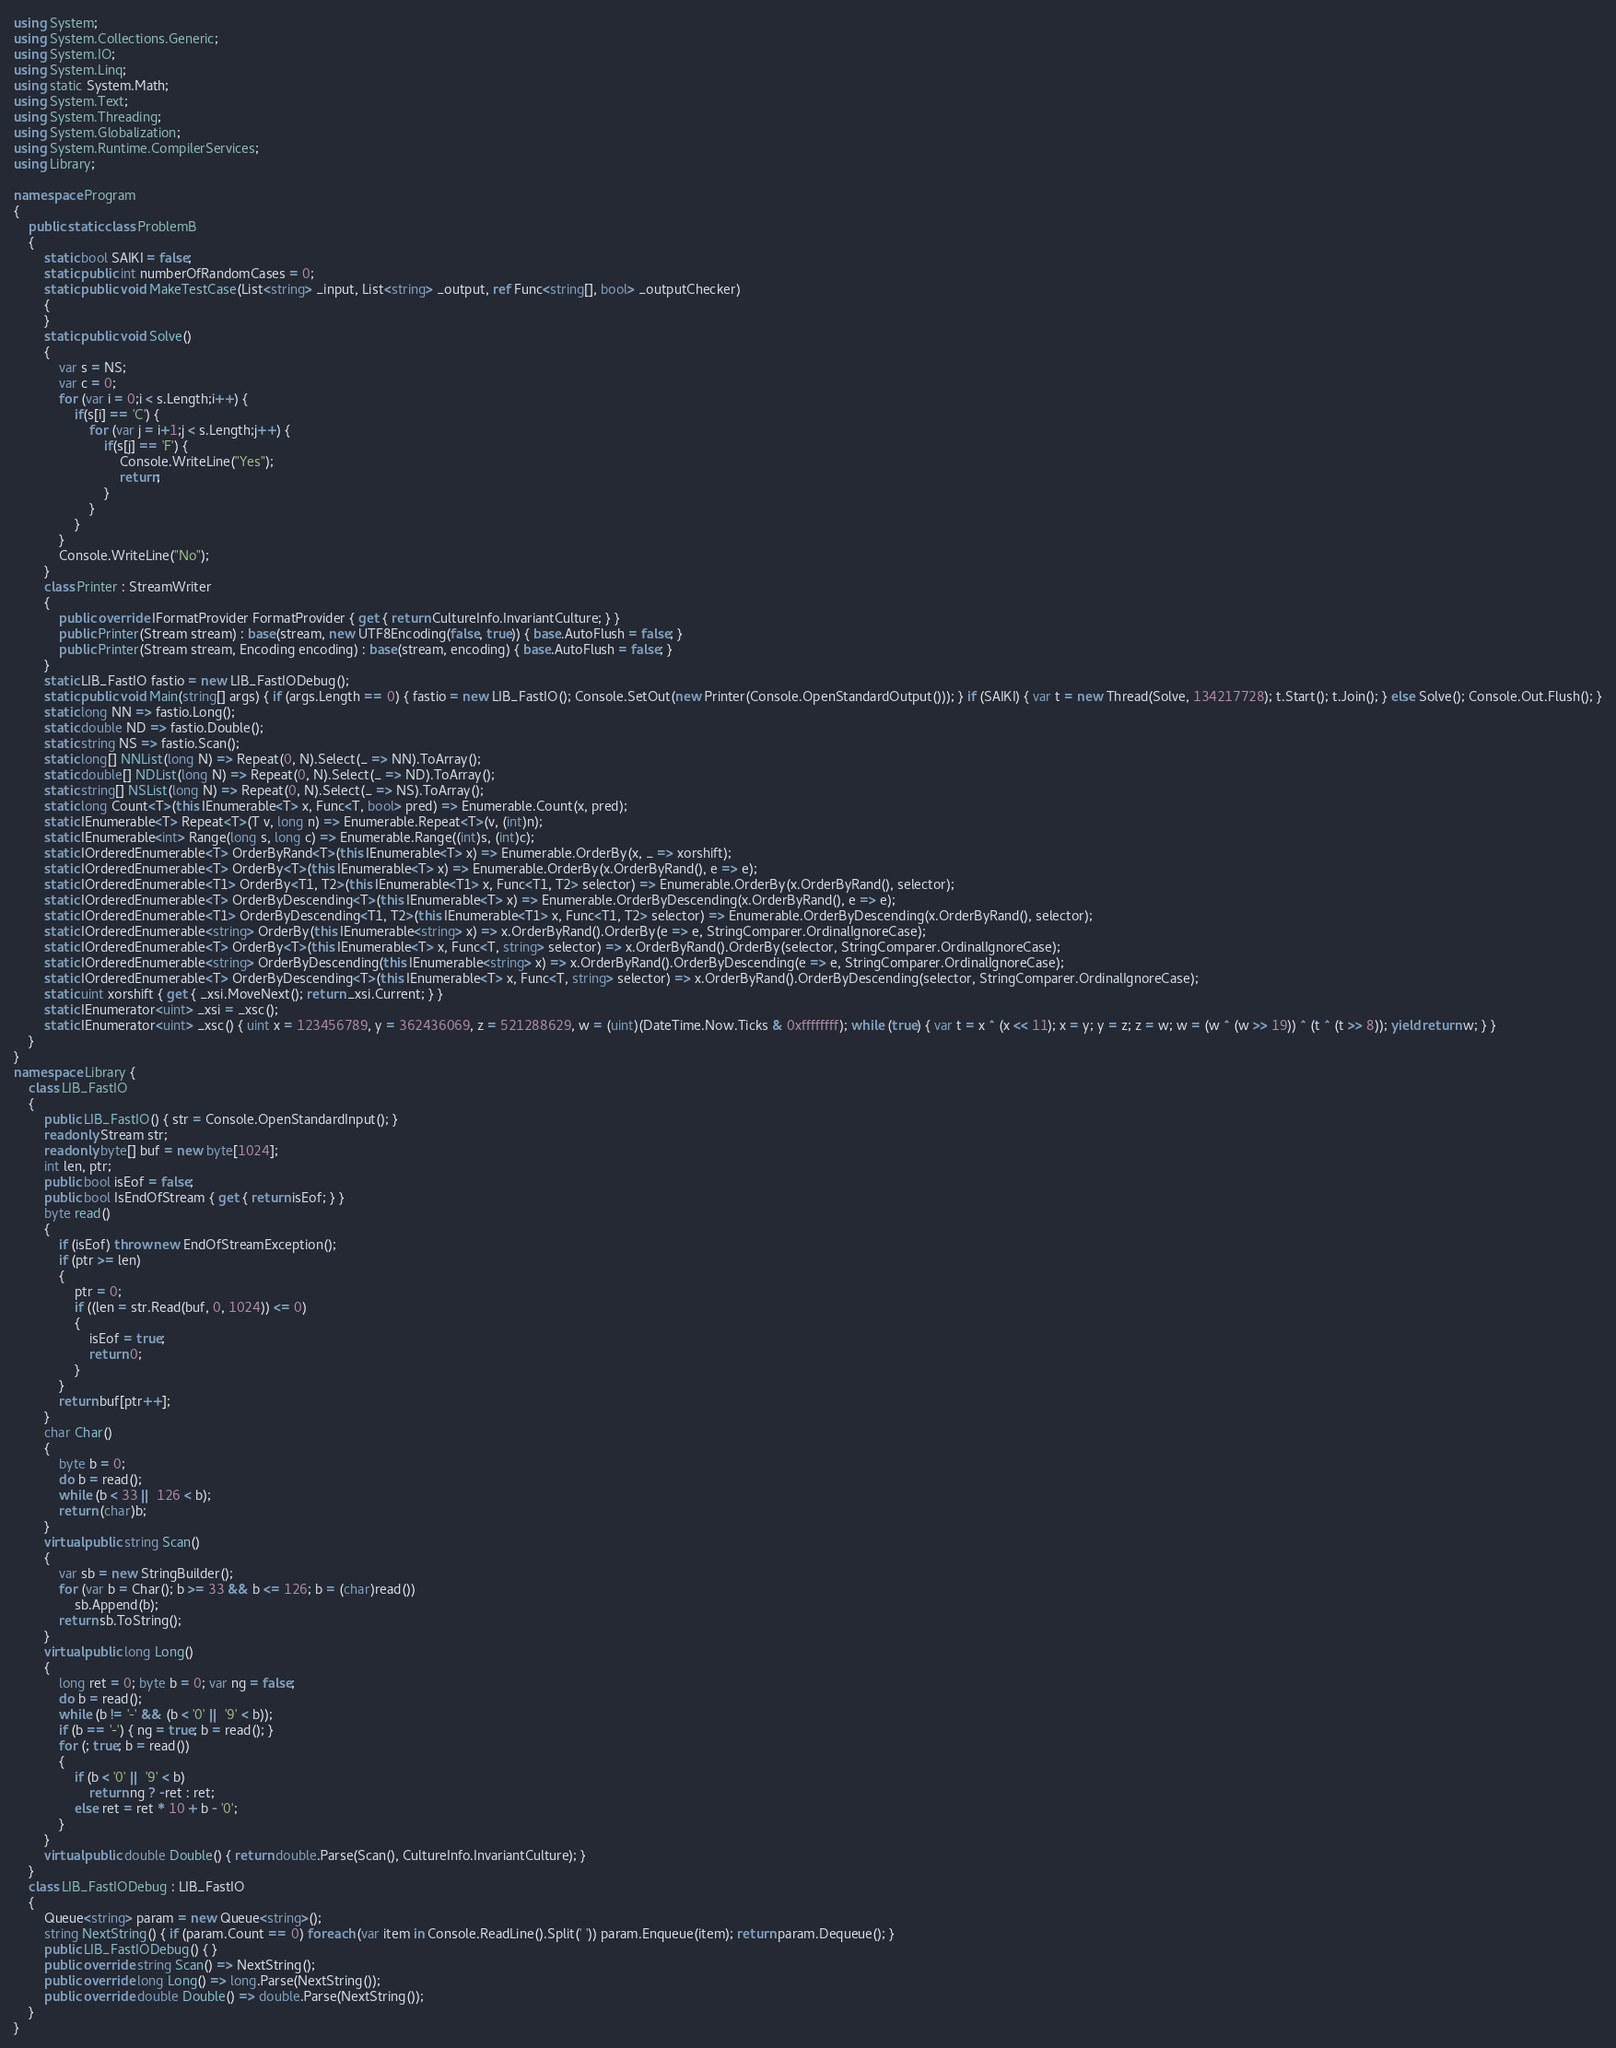Convert code to text. <code><loc_0><loc_0><loc_500><loc_500><_C#_>using System;
using System.Collections.Generic;
using System.IO;
using System.Linq;
using static System.Math;
using System.Text;
using System.Threading;
using System.Globalization;
using System.Runtime.CompilerServices;
using Library;

namespace Program
{
    public static class ProblemB
    {
        static bool SAIKI = false;
        static public int numberOfRandomCases = 0;
        static public void MakeTestCase(List<string> _input, List<string> _output, ref Func<string[], bool> _outputChecker)
        {
        }
        static public void Solve()
        {
            var s = NS;
            var c = 0;
            for (var i = 0;i < s.Length;i++) {
                if(s[i] == 'C') {
                    for (var j = i+1;j < s.Length;j++) {
                        if(s[j] == 'F') {
                            Console.WriteLine("Yes");
                            return;
                        }
                    }
                }
            }
            Console.WriteLine("No");
        }
        class Printer : StreamWriter
        {
            public override IFormatProvider FormatProvider { get { return CultureInfo.InvariantCulture; } }
            public Printer(Stream stream) : base(stream, new UTF8Encoding(false, true)) { base.AutoFlush = false; }
            public Printer(Stream stream, Encoding encoding) : base(stream, encoding) { base.AutoFlush = false; }
        }
        static LIB_FastIO fastio = new LIB_FastIODebug();
        static public void Main(string[] args) { if (args.Length == 0) { fastio = new LIB_FastIO(); Console.SetOut(new Printer(Console.OpenStandardOutput())); } if (SAIKI) { var t = new Thread(Solve, 134217728); t.Start(); t.Join(); } else Solve(); Console.Out.Flush(); }
        static long NN => fastio.Long();
        static double ND => fastio.Double();
        static string NS => fastio.Scan();
        static long[] NNList(long N) => Repeat(0, N).Select(_ => NN).ToArray();
        static double[] NDList(long N) => Repeat(0, N).Select(_ => ND).ToArray();
        static string[] NSList(long N) => Repeat(0, N).Select(_ => NS).ToArray();
        static long Count<T>(this IEnumerable<T> x, Func<T, bool> pred) => Enumerable.Count(x, pred);
        static IEnumerable<T> Repeat<T>(T v, long n) => Enumerable.Repeat<T>(v, (int)n);
        static IEnumerable<int> Range(long s, long c) => Enumerable.Range((int)s, (int)c);
        static IOrderedEnumerable<T> OrderByRand<T>(this IEnumerable<T> x) => Enumerable.OrderBy(x, _ => xorshift);
        static IOrderedEnumerable<T> OrderBy<T>(this IEnumerable<T> x) => Enumerable.OrderBy(x.OrderByRand(), e => e);
        static IOrderedEnumerable<T1> OrderBy<T1, T2>(this IEnumerable<T1> x, Func<T1, T2> selector) => Enumerable.OrderBy(x.OrderByRand(), selector);
        static IOrderedEnumerable<T> OrderByDescending<T>(this IEnumerable<T> x) => Enumerable.OrderByDescending(x.OrderByRand(), e => e);
        static IOrderedEnumerable<T1> OrderByDescending<T1, T2>(this IEnumerable<T1> x, Func<T1, T2> selector) => Enumerable.OrderByDescending(x.OrderByRand(), selector);
        static IOrderedEnumerable<string> OrderBy(this IEnumerable<string> x) => x.OrderByRand().OrderBy(e => e, StringComparer.OrdinalIgnoreCase);
        static IOrderedEnumerable<T> OrderBy<T>(this IEnumerable<T> x, Func<T, string> selector) => x.OrderByRand().OrderBy(selector, StringComparer.OrdinalIgnoreCase);
        static IOrderedEnumerable<string> OrderByDescending(this IEnumerable<string> x) => x.OrderByRand().OrderByDescending(e => e, StringComparer.OrdinalIgnoreCase);
        static IOrderedEnumerable<T> OrderByDescending<T>(this IEnumerable<T> x, Func<T, string> selector) => x.OrderByRand().OrderByDescending(selector, StringComparer.OrdinalIgnoreCase);
        static uint xorshift { get { _xsi.MoveNext(); return _xsi.Current; } }
        static IEnumerator<uint> _xsi = _xsc();
        static IEnumerator<uint> _xsc() { uint x = 123456789, y = 362436069, z = 521288629, w = (uint)(DateTime.Now.Ticks & 0xffffffff); while (true) { var t = x ^ (x << 11); x = y; y = z; z = w; w = (w ^ (w >> 19)) ^ (t ^ (t >> 8)); yield return w; } }
    }
}
namespace Library {
    class LIB_FastIO
    {
        public LIB_FastIO() { str = Console.OpenStandardInput(); }
        readonly Stream str;
        readonly byte[] buf = new byte[1024];
        int len, ptr;
        public bool isEof = false;
        public bool IsEndOfStream { get { return isEof; } }
        byte read()
        {
            if (isEof) throw new EndOfStreamException();
            if (ptr >= len)
            {
                ptr = 0;
                if ((len = str.Read(buf, 0, 1024)) <= 0)
                {
                    isEof = true;
                    return 0;
                }
            }
            return buf[ptr++];
        }
        char Char()
        {
            byte b = 0;
            do b = read();
            while (b < 33 || 126 < b);
            return (char)b;
        }
        virtual public string Scan()
        {
            var sb = new StringBuilder();
            for (var b = Char(); b >= 33 && b <= 126; b = (char)read())
                sb.Append(b);
            return sb.ToString();
        }
        virtual public long Long()
        {
            long ret = 0; byte b = 0; var ng = false;
            do b = read();
            while (b != '-' && (b < '0' || '9' < b));
            if (b == '-') { ng = true; b = read(); }
            for (; true; b = read())
            {
                if (b < '0' || '9' < b)
                    return ng ? -ret : ret;
                else ret = ret * 10 + b - '0';
            }
        }
        virtual public double Double() { return double.Parse(Scan(), CultureInfo.InvariantCulture); }
    }
    class LIB_FastIODebug : LIB_FastIO
    {
        Queue<string> param = new Queue<string>();
        string NextString() { if (param.Count == 0) foreach (var item in Console.ReadLine().Split(' ')) param.Enqueue(item); return param.Dequeue(); }
        public LIB_FastIODebug() { }
        public override string Scan() => NextString();
        public override long Long() => long.Parse(NextString());
        public override double Double() => double.Parse(NextString());
    }
}
</code> 